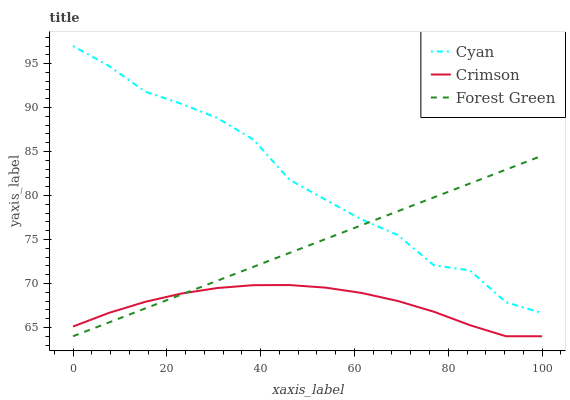Does Crimson have the minimum area under the curve?
Answer yes or no. Yes. Does Cyan have the maximum area under the curve?
Answer yes or no. Yes. Does Forest Green have the minimum area under the curve?
Answer yes or no. No. Does Forest Green have the maximum area under the curve?
Answer yes or no. No. Is Forest Green the smoothest?
Answer yes or no. Yes. Is Cyan the roughest?
Answer yes or no. Yes. Is Cyan the smoothest?
Answer yes or no. No. Is Forest Green the roughest?
Answer yes or no. No. Does Crimson have the lowest value?
Answer yes or no. Yes. Does Cyan have the lowest value?
Answer yes or no. No. Does Cyan have the highest value?
Answer yes or no. Yes. Does Forest Green have the highest value?
Answer yes or no. No. Is Crimson less than Cyan?
Answer yes or no. Yes. Is Cyan greater than Crimson?
Answer yes or no. Yes. Does Forest Green intersect Crimson?
Answer yes or no. Yes. Is Forest Green less than Crimson?
Answer yes or no. No. Is Forest Green greater than Crimson?
Answer yes or no. No. Does Crimson intersect Cyan?
Answer yes or no. No. 